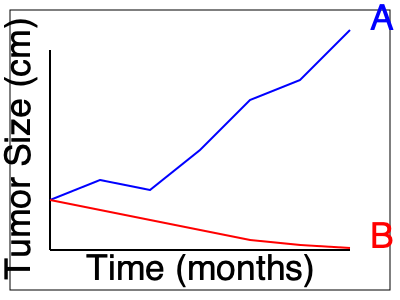As an oncologist, you're presented with genetic mutation data from two patient groups (A and B) undergoing different targeted therapies for the same type of cancer. The graph shows tumor size changes over time. Which genetic mutation is most likely present in group A, and what does this imply about the effectiveness of the therapy?

a) BRAF V600E mutation, indicating high therapy effectiveness
b) EGFR T790M mutation, suggesting therapy resistance
c) ALK rearrangement, showing moderate therapy response
d) KRAS G12C mutation, demonstrating therapy ineffectiveness To interpret this genetic mutation diagram in cancer research, we need to analyze the graph and apply our knowledge of common cancer-associated mutations and their impact on treatment outcomes:

1. Observe the graph: There are two lines representing groups A (blue) and B (red).

2. Interpret the trends:
   - Group A shows a significant decrease in tumor size over time.
   - Group B shows a slight increase in tumor size over time.

3. Consider the implications:
   - Group A's trend suggests an effective therapy.
   - Group B's trend indicates an ineffective therapy or possible resistance.

4. Analyze the given mutation options:
   a) BRAF V600E: Common in melanoma, typically responds well to targeted therapies.
   b) EGFR T790M: Associated with resistance to EGFR tyrosine kinase inhibitors in lung cancer.
   c) ALK rearrangement: Found in some lung cancers, usually responds to ALK inhibitors.
   d) KRAS G12C: Historically difficult to target, associated with poor treatment outcomes.

5. Match the mutation to the observed trend:
   - Group A's dramatic tumor size reduction aligns best with a mutation that responds well to targeted therapy.
   - Among the options, BRAF V600E is known for its good response to targeted treatments.

6. Conclude: The BRAF V600E mutation is most likely present in group A, as it shows the best match with the observed treatment effectiveness.

This implies that the therapy used for group A is highly effective against tumors harboring the BRAF V600E mutation, which is consistent with clinical outcomes seen with BRAF inhibitors in cancers like melanoma.
Answer: a) BRAF V600E mutation, indicating high therapy effectiveness 